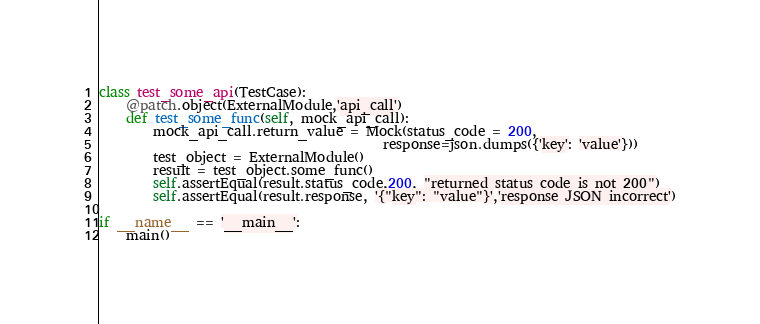<code> <loc_0><loc_0><loc_500><loc_500><_Python_>
class test_some_api(TestCase):
    @patch.object(ExternalModule,'api_call')
    def test_some_func(self, mock_api_call):
        mock_api_call.return_value = Mock(status_code = 200,
                                          response=json.dumps({'key': 'value'}))
        test_object = ExternalModule()
        result = test_object.some_func()
        self.assertEqual(result.status_code,200, "returned status code is not 200")
        self.assertEqual(result.response, '{"key": "value"}','response JSON incorrect')

if __name__ == '__main__':
    main()
</code> 